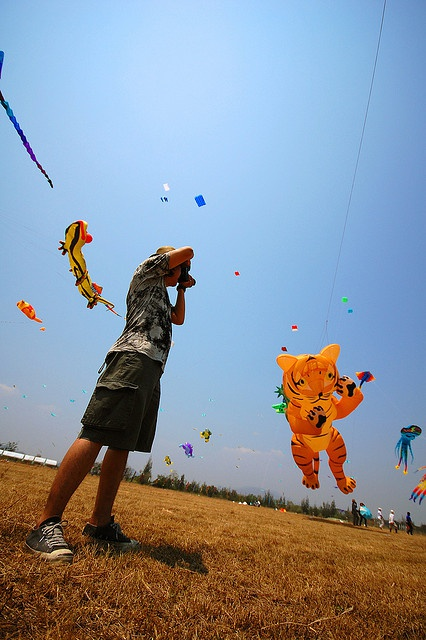Describe the objects in this image and their specific colors. I can see people in lightblue, black, maroon, and gray tones, kite in lightblue, red, brown, and orange tones, kite in lightblue, darkgray, and lavender tones, kite in lightblue, black, olive, orange, and maroon tones, and kite in lightblue, teal, black, navy, and gray tones in this image. 